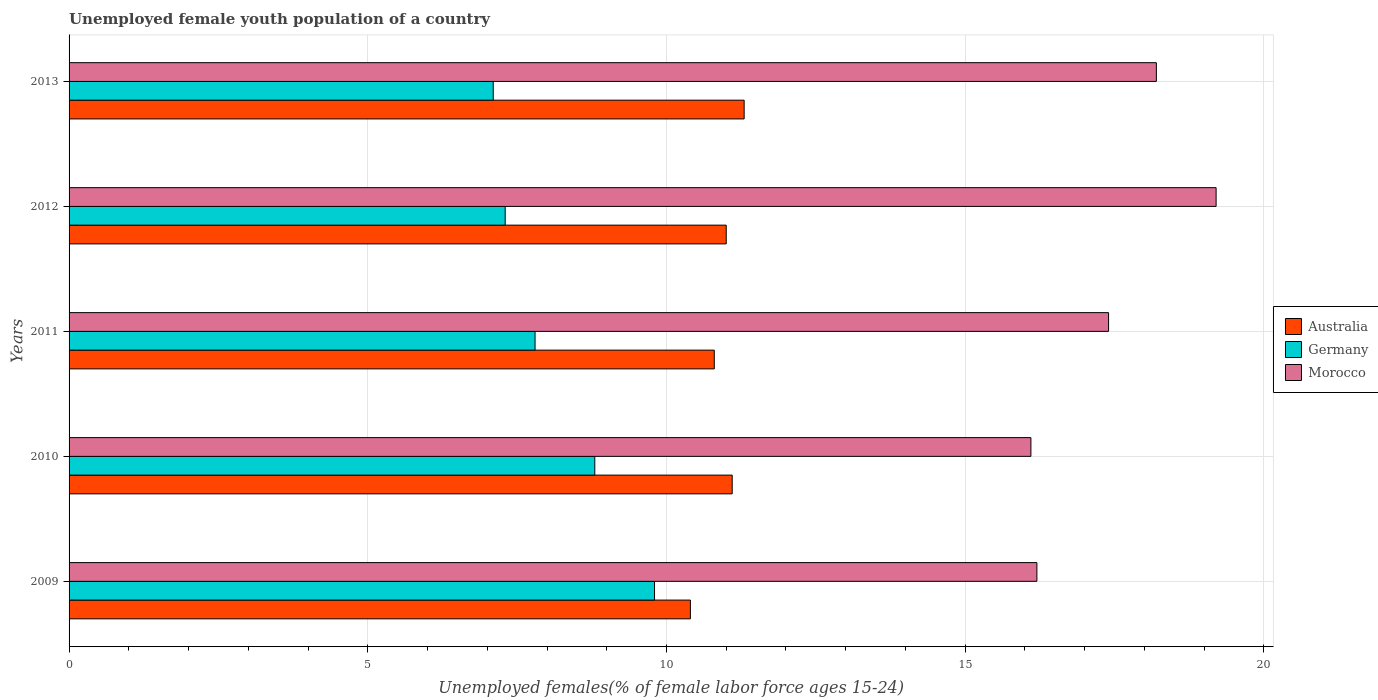How many groups of bars are there?
Your answer should be compact. 5. Are the number of bars per tick equal to the number of legend labels?
Keep it short and to the point. Yes. Are the number of bars on each tick of the Y-axis equal?
Your answer should be compact. Yes. How many bars are there on the 5th tick from the top?
Ensure brevity in your answer.  3. How many bars are there on the 5th tick from the bottom?
Your answer should be very brief. 3. In how many cases, is the number of bars for a given year not equal to the number of legend labels?
Your response must be concise. 0. What is the percentage of unemployed female youth population in Australia in 2013?
Your response must be concise. 11.3. Across all years, what is the maximum percentage of unemployed female youth population in Germany?
Provide a succinct answer. 9.8. Across all years, what is the minimum percentage of unemployed female youth population in Morocco?
Offer a very short reply. 16.1. In which year was the percentage of unemployed female youth population in Germany minimum?
Your answer should be compact. 2013. What is the total percentage of unemployed female youth population in Germany in the graph?
Your response must be concise. 40.8. What is the difference between the percentage of unemployed female youth population in Germany in 2009 and that in 2013?
Give a very brief answer. 2.7. What is the difference between the percentage of unemployed female youth population in Australia in 2010 and the percentage of unemployed female youth population in Morocco in 2013?
Offer a very short reply. -7.1. What is the average percentage of unemployed female youth population in Morocco per year?
Provide a succinct answer. 17.42. In the year 2013, what is the difference between the percentage of unemployed female youth population in Morocco and percentage of unemployed female youth population in Germany?
Make the answer very short. 11.1. What is the ratio of the percentage of unemployed female youth population in Australia in 2010 to that in 2011?
Your response must be concise. 1.03. Is the percentage of unemployed female youth population in Germany in 2012 less than that in 2013?
Provide a succinct answer. No. What is the difference between the highest and the lowest percentage of unemployed female youth population in Morocco?
Your answer should be very brief. 3.1. In how many years, is the percentage of unemployed female youth population in Germany greater than the average percentage of unemployed female youth population in Germany taken over all years?
Make the answer very short. 2. What does the 1st bar from the top in 2012 represents?
Ensure brevity in your answer.  Morocco. What does the 2nd bar from the bottom in 2009 represents?
Give a very brief answer. Germany. How many bars are there?
Your answer should be compact. 15. Does the graph contain grids?
Give a very brief answer. Yes. Where does the legend appear in the graph?
Offer a terse response. Center right. How many legend labels are there?
Your response must be concise. 3. What is the title of the graph?
Offer a terse response. Unemployed female youth population of a country. What is the label or title of the X-axis?
Offer a very short reply. Unemployed females(% of female labor force ages 15-24). What is the Unemployed females(% of female labor force ages 15-24) of Australia in 2009?
Provide a short and direct response. 10.4. What is the Unemployed females(% of female labor force ages 15-24) of Germany in 2009?
Offer a terse response. 9.8. What is the Unemployed females(% of female labor force ages 15-24) in Morocco in 2009?
Make the answer very short. 16.2. What is the Unemployed females(% of female labor force ages 15-24) of Australia in 2010?
Offer a terse response. 11.1. What is the Unemployed females(% of female labor force ages 15-24) in Germany in 2010?
Your response must be concise. 8.8. What is the Unemployed females(% of female labor force ages 15-24) of Morocco in 2010?
Your answer should be compact. 16.1. What is the Unemployed females(% of female labor force ages 15-24) of Australia in 2011?
Ensure brevity in your answer.  10.8. What is the Unemployed females(% of female labor force ages 15-24) of Germany in 2011?
Your answer should be very brief. 7.8. What is the Unemployed females(% of female labor force ages 15-24) of Morocco in 2011?
Provide a succinct answer. 17.4. What is the Unemployed females(% of female labor force ages 15-24) in Australia in 2012?
Provide a short and direct response. 11. What is the Unemployed females(% of female labor force ages 15-24) of Germany in 2012?
Your answer should be compact. 7.3. What is the Unemployed females(% of female labor force ages 15-24) of Morocco in 2012?
Provide a short and direct response. 19.2. What is the Unemployed females(% of female labor force ages 15-24) in Australia in 2013?
Make the answer very short. 11.3. What is the Unemployed females(% of female labor force ages 15-24) in Germany in 2013?
Make the answer very short. 7.1. What is the Unemployed females(% of female labor force ages 15-24) of Morocco in 2013?
Keep it short and to the point. 18.2. Across all years, what is the maximum Unemployed females(% of female labor force ages 15-24) of Australia?
Your answer should be compact. 11.3. Across all years, what is the maximum Unemployed females(% of female labor force ages 15-24) in Germany?
Offer a terse response. 9.8. Across all years, what is the maximum Unemployed females(% of female labor force ages 15-24) in Morocco?
Ensure brevity in your answer.  19.2. Across all years, what is the minimum Unemployed females(% of female labor force ages 15-24) of Australia?
Your answer should be very brief. 10.4. Across all years, what is the minimum Unemployed females(% of female labor force ages 15-24) in Germany?
Make the answer very short. 7.1. Across all years, what is the minimum Unemployed females(% of female labor force ages 15-24) of Morocco?
Ensure brevity in your answer.  16.1. What is the total Unemployed females(% of female labor force ages 15-24) in Australia in the graph?
Your response must be concise. 54.6. What is the total Unemployed females(% of female labor force ages 15-24) of Germany in the graph?
Your answer should be compact. 40.8. What is the total Unemployed females(% of female labor force ages 15-24) of Morocco in the graph?
Offer a terse response. 87.1. What is the difference between the Unemployed females(% of female labor force ages 15-24) of Germany in 2009 and that in 2010?
Offer a very short reply. 1. What is the difference between the Unemployed females(% of female labor force ages 15-24) of Morocco in 2009 and that in 2010?
Offer a terse response. 0.1. What is the difference between the Unemployed females(% of female labor force ages 15-24) in Australia in 2009 and that in 2011?
Your answer should be compact. -0.4. What is the difference between the Unemployed females(% of female labor force ages 15-24) of Germany in 2009 and that in 2011?
Your response must be concise. 2. What is the difference between the Unemployed females(% of female labor force ages 15-24) in Morocco in 2009 and that in 2011?
Give a very brief answer. -1.2. What is the difference between the Unemployed females(% of female labor force ages 15-24) in Germany in 2009 and that in 2012?
Provide a succinct answer. 2.5. What is the difference between the Unemployed females(% of female labor force ages 15-24) in Germany in 2009 and that in 2013?
Offer a terse response. 2.7. What is the difference between the Unemployed females(% of female labor force ages 15-24) of Australia in 2010 and that in 2011?
Make the answer very short. 0.3. What is the difference between the Unemployed females(% of female labor force ages 15-24) of Morocco in 2010 and that in 2011?
Provide a succinct answer. -1.3. What is the difference between the Unemployed females(% of female labor force ages 15-24) in Australia in 2010 and that in 2012?
Make the answer very short. 0.1. What is the difference between the Unemployed females(% of female labor force ages 15-24) in Australia in 2010 and that in 2013?
Provide a short and direct response. -0.2. What is the difference between the Unemployed females(% of female labor force ages 15-24) of Morocco in 2010 and that in 2013?
Offer a terse response. -2.1. What is the difference between the Unemployed females(% of female labor force ages 15-24) in Australia in 2011 and that in 2013?
Offer a terse response. -0.5. What is the difference between the Unemployed females(% of female labor force ages 15-24) of Germany in 2011 and that in 2013?
Your response must be concise. 0.7. What is the difference between the Unemployed females(% of female labor force ages 15-24) in Germany in 2012 and that in 2013?
Your response must be concise. 0.2. What is the difference between the Unemployed females(% of female labor force ages 15-24) of Morocco in 2012 and that in 2013?
Keep it short and to the point. 1. What is the difference between the Unemployed females(% of female labor force ages 15-24) of Australia in 2009 and the Unemployed females(% of female labor force ages 15-24) of Germany in 2010?
Provide a short and direct response. 1.6. What is the difference between the Unemployed females(% of female labor force ages 15-24) in Australia in 2009 and the Unemployed females(% of female labor force ages 15-24) in Morocco in 2012?
Your response must be concise. -8.8. What is the difference between the Unemployed females(% of female labor force ages 15-24) of Australia in 2009 and the Unemployed females(% of female labor force ages 15-24) of Germany in 2013?
Offer a very short reply. 3.3. What is the difference between the Unemployed females(% of female labor force ages 15-24) in Australia in 2009 and the Unemployed females(% of female labor force ages 15-24) in Morocco in 2013?
Offer a terse response. -7.8. What is the difference between the Unemployed females(% of female labor force ages 15-24) in Germany in 2009 and the Unemployed females(% of female labor force ages 15-24) in Morocco in 2013?
Your response must be concise. -8.4. What is the difference between the Unemployed females(% of female labor force ages 15-24) of Germany in 2010 and the Unemployed females(% of female labor force ages 15-24) of Morocco in 2012?
Keep it short and to the point. -10.4. What is the difference between the Unemployed females(% of female labor force ages 15-24) in Australia in 2010 and the Unemployed females(% of female labor force ages 15-24) in Germany in 2013?
Offer a terse response. 4. What is the difference between the Unemployed females(% of female labor force ages 15-24) of Germany in 2011 and the Unemployed females(% of female labor force ages 15-24) of Morocco in 2012?
Give a very brief answer. -11.4. What is the difference between the Unemployed females(% of female labor force ages 15-24) in Germany in 2011 and the Unemployed females(% of female labor force ages 15-24) in Morocco in 2013?
Offer a terse response. -10.4. What is the difference between the Unemployed females(% of female labor force ages 15-24) in Germany in 2012 and the Unemployed females(% of female labor force ages 15-24) in Morocco in 2013?
Your answer should be compact. -10.9. What is the average Unemployed females(% of female labor force ages 15-24) of Australia per year?
Offer a terse response. 10.92. What is the average Unemployed females(% of female labor force ages 15-24) in Germany per year?
Provide a short and direct response. 8.16. What is the average Unemployed females(% of female labor force ages 15-24) in Morocco per year?
Provide a succinct answer. 17.42. In the year 2009, what is the difference between the Unemployed females(% of female labor force ages 15-24) in Australia and Unemployed females(% of female labor force ages 15-24) in Germany?
Ensure brevity in your answer.  0.6. In the year 2009, what is the difference between the Unemployed females(% of female labor force ages 15-24) in Australia and Unemployed females(% of female labor force ages 15-24) in Morocco?
Your answer should be compact. -5.8. In the year 2010, what is the difference between the Unemployed females(% of female labor force ages 15-24) in Germany and Unemployed females(% of female labor force ages 15-24) in Morocco?
Your answer should be compact. -7.3. In the year 2011, what is the difference between the Unemployed females(% of female labor force ages 15-24) of Australia and Unemployed females(% of female labor force ages 15-24) of Germany?
Offer a terse response. 3. In the year 2011, what is the difference between the Unemployed females(% of female labor force ages 15-24) of Australia and Unemployed females(% of female labor force ages 15-24) of Morocco?
Provide a short and direct response. -6.6. In the year 2012, what is the difference between the Unemployed females(% of female labor force ages 15-24) in Australia and Unemployed females(% of female labor force ages 15-24) in Germany?
Your answer should be very brief. 3.7. In the year 2012, what is the difference between the Unemployed females(% of female labor force ages 15-24) of Australia and Unemployed females(% of female labor force ages 15-24) of Morocco?
Offer a very short reply. -8.2. In the year 2013, what is the difference between the Unemployed females(% of female labor force ages 15-24) of Australia and Unemployed females(% of female labor force ages 15-24) of Morocco?
Offer a very short reply. -6.9. In the year 2013, what is the difference between the Unemployed females(% of female labor force ages 15-24) in Germany and Unemployed females(% of female labor force ages 15-24) in Morocco?
Your answer should be very brief. -11.1. What is the ratio of the Unemployed females(% of female labor force ages 15-24) in Australia in 2009 to that in 2010?
Your response must be concise. 0.94. What is the ratio of the Unemployed females(% of female labor force ages 15-24) in Germany in 2009 to that in 2010?
Make the answer very short. 1.11. What is the ratio of the Unemployed females(% of female labor force ages 15-24) of Morocco in 2009 to that in 2010?
Give a very brief answer. 1.01. What is the ratio of the Unemployed females(% of female labor force ages 15-24) of Germany in 2009 to that in 2011?
Your answer should be very brief. 1.26. What is the ratio of the Unemployed females(% of female labor force ages 15-24) in Australia in 2009 to that in 2012?
Your answer should be compact. 0.95. What is the ratio of the Unemployed females(% of female labor force ages 15-24) of Germany in 2009 to that in 2012?
Give a very brief answer. 1.34. What is the ratio of the Unemployed females(% of female labor force ages 15-24) of Morocco in 2009 to that in 2012?
Your answer should be compact. 0.84. What is the ratio of the Unemployed females(% of female labor force ages 15-24) in Australia in 2009 to that in 2013?
Offer a terse response. 0.92. What is the ratio of the Unemployed females(% of female labor force ages 15-24) in Germany in 2009 to that in 2013?
Your answer should be compact. 1.38. What is the ratio of the Unemployed females(% of female labor force ages 15-24) in Morocco in 2009 to that in 2013?
Your response must be concise. 0.89. What is the ratio of the Unemployed females(% of female labor force ages 15-24) in Australia in 2010 to that in 2011?
Give a very brief answer. 1.03. What is the ratio of the Unemployed females(% of female labor force ages 15-24) of Germany in 2010 to that in 2011?
Provide a succinct answer. 1.13. What is the ratio of the Unemployed females(% of female labor force ages 15-24) in Morocco in 2010 to that in 2011?
Make the answer very short. 0.93. What is the ratio of the Unemployed females(% of female labor force ages 15-24) in Australia in 2010 to that in 2012?
Offer a very short reply. 1.01. What is the ratio of the Unemployed females(% of female labor force ages 15-24) of Germany in 2010 to that in 2012?
Ensure brevity in your answer.  1.21. What is the ratio of the Unemployed females(% of female labor force ages 15-24) of Morocco in 2010 to that in 2012?
Provide a succinct answer. 0.84. What is the ratio of the Unemployed females(% of female labor force ages 15-24) in Australia in 2010 to that in 2013?
Keep it short and to the point. 0.98. What is the ratio of the Unemployed females(% of female labor force ages 15-24) in Germany in 2010 to that in 2013?
Your response must be concise. 1.24. What is the ratio of the Unemployed females(% of female labor force ages 15-24) of Morocco in 2010 to that in 2013?
Make the answer very short. 0.88. What is the ratio of the Unemployed females(% of female labor force ages 15-24) in Australia in 2011 to that in 2012?
Ensure brevity in your answer.  0.98. What is the ratio of the Unemployed females(% of female labor force ages 15-24) of Germany in 2011 to that in 2012?
Your answer should be compact. 1.07. What is the ratio of the Unemployed females(% of female labor force ages 15-24) of Morocco in 2011 to that in 2012?
Make the answer very short. 0.91. What is the ratio of the Unemployed females(% of female labor force ages 15-24) in Australia in 2011 to that in 2013?
Provide a succinct answer. 0.96. What is the ratio of the Unemployed females(% of female labor force ages 15-24) of Germany in 2011 to that in 2013?
Make the answer very short. 1.1. What is the ratio of the Unemployed females(% of female labor force ages 15-24) of Morocco in 2011 to that in 2013?
Keep it short and to the point. 0.96. What is the ratio of the Unemployed females(% of female labor force ages 15-24) of Australia in 2012 to that in 2013?
Offer a terse response. 0.97. What is the ratio of the Unemployed females(% of female labor force ages 15-24) in Germany in 2012 to that in 2013?
Provide a succinct answer. 1.03. What is the ratio of the Unemployed females(% of female labor force ages 15-24) in Morocco in 2012 to that in 2013?
Offer a terse response. 1.05. What is the difference between the highest and the second highest Unemployed females(% of female labor force ages 15-24) in Morocco?
Give a very brief answer. 1. 